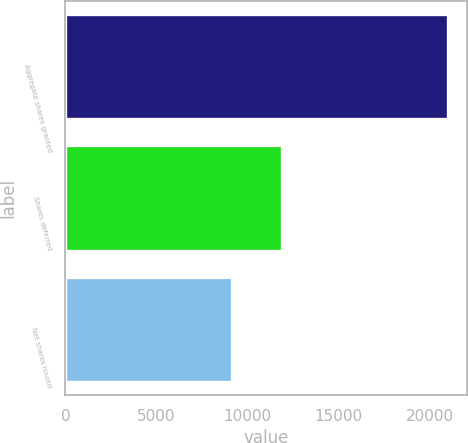Convert chart to OTSL. <chart><loc_0><loc_0><loc_500><loc_500><bar_chart><fcel>Aggregate shares granted<fcel>Shares deferred<fcel>Net shares issued<nl><fcel>21023<fcel>11882<fcel>9141<nl></chart> 